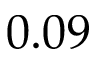Convert formula to latex. <formula><loc_0><loc_0><loc_500><loc_500>0 . 0 9</formula> 